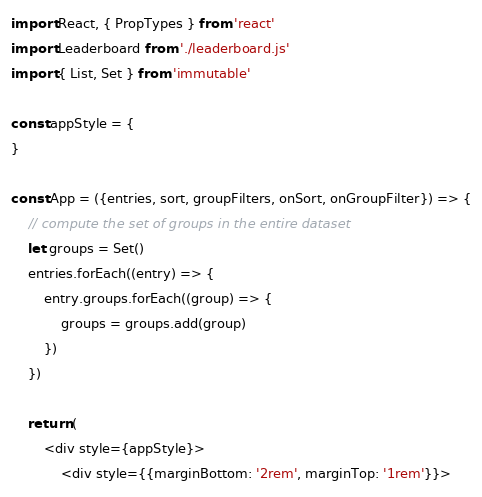Convert code to text. <code><loc_0><loc_0><loc_500><loc_500><_JavaScript_>import React, { PropTypes } from 'react'
import Leaderboard from './leaderboard.js'
import { List, Set } from 'immutable'

const appStyle = {
}

const App = ({entries, sort, groupFilters, onSort, onGroupFilter}) => {
	// compute the set of groups in the entire dataset
	let groups = Set()
	entries.forEach((entry) => {
		entry.groups.forEach((group) => {
			groups = groups.add(group)
		})
	})

	return (
		<div style={appStyle}>
			<div style={{marginBottom: '2rem', marginTop: '1rem'}}></code> 